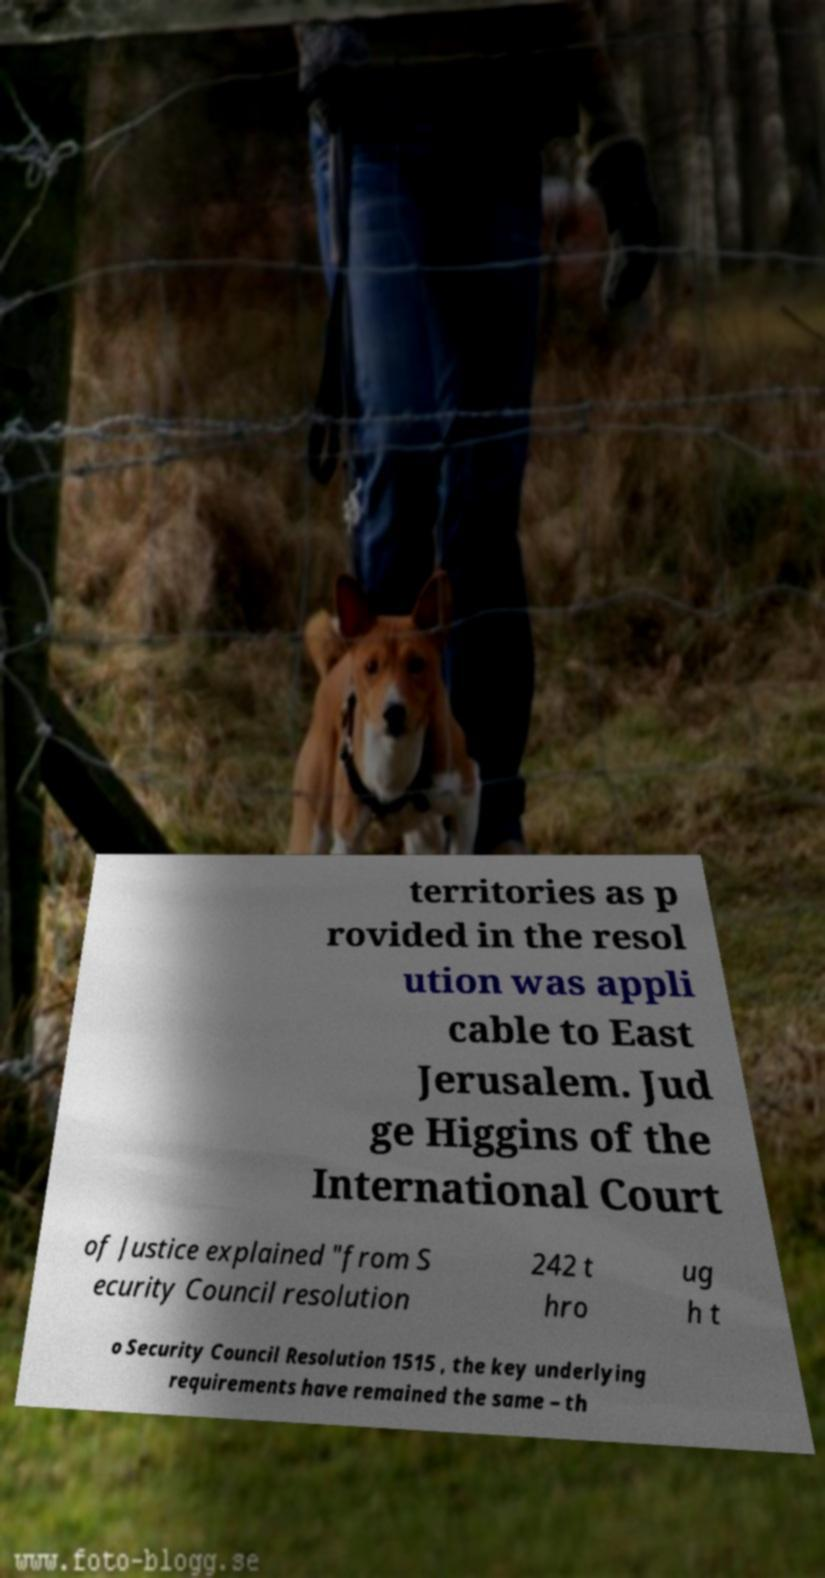What messages or text are displayed in this image? I need them in a readable, typed format. territories as p rovided in the resol ution was appli cable to East Jerusalem. Jud ge Higgins of the International Court of Justice explained "from S ecurity Council resolution 242 t hro ug h t o Security Council Resolution 1515 , the key underlying requirements have remained the same – th 